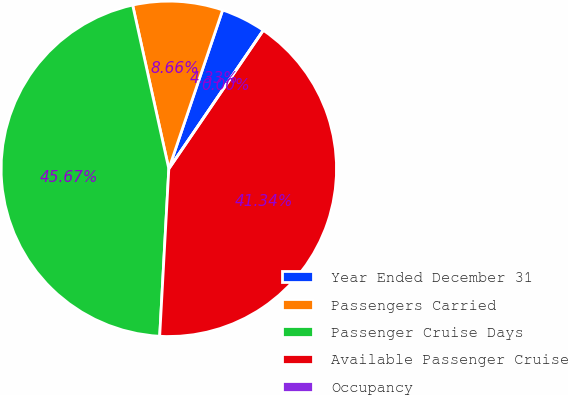<chart> <loc_0><loc_0><loc_500><loc_500><pie_chart><fcel>Year Ended December 31<fcel>Passengers Carried<fcel>Passenger Cruise Days<fcel>Available Passenger Cruise<fcel>Occupancy<nl><fcel>4.33%<fcel>8.66%<fcel>45.67%<fcel>41.34%<fcel>0.0%<nl></chart> 